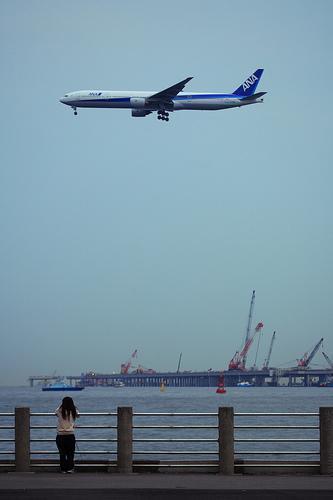How many people are in the picture?
Give a very brief answer. 1. 